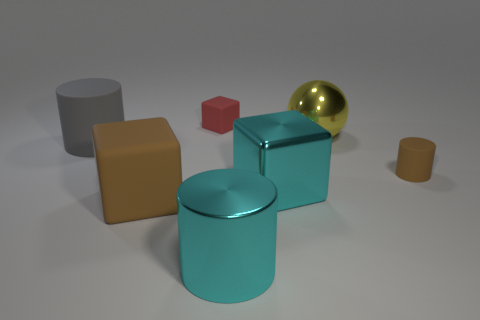Subtract 1 cylinders. How many cylinders are left? 2 Subtract all matte cylinders. How many cylinders are left? 1 Add 3 brown matte cubes. How many objects exist? 10 Subtract all cylinders. How many objects are left? 4 Subtract all small rubber objects. Subtract all cylinders. How many objects are left? 2 Add 2 small red rubber cubes. How many small red rubber cubes are left? 3 Add 6 matte balls. How many matte balls exist? 6 Subtract 0 yellow blocks. How many objects are left? 7 